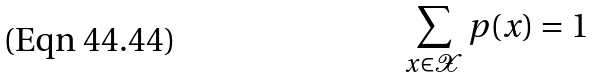<formula> <loc_0><loc_0><loc_500><loc_500>\sum _ { x \in \mathcal { X } } p ( x ) = 1</formula> 